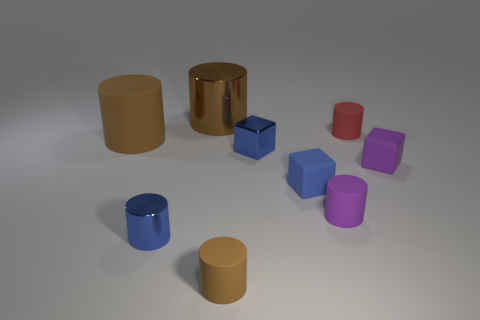The tiny rubber object that is the same color as the shiny cube is what shape?
Your response must be concise. Cube. What number of blue metal objects are the same shape as the tiny brown matte object?
Provide a short and direct response. 1. There is a small purple object that is the same shape as the small brown matte thing; what is its material?
Your response must be concise. Rubber. Is the number of tiny blue matte objects on the left side of the small brown rubber cylinder greater than the number of red cylinders?
Your response must be concise. No. What color is the shiny cube?
Make the answer very short. Blue. There is a rubber object that is right of the rubber cylinder behind the large brown thing in front of the red cylinder; what is its shape?
Give a very brief answer. Cube. What is the brown object that is in front of the tiny red object and behind the small brown matte cylinder made of?
Give a very brief answer. Rubber. The tiny purple object that is right of the tiny purple rubber cylinder in front of the metallic cube is what shape?
Provide a short and direct response. Cube. Is there any other thing that is the same color as the small shiny cylinder?
Give a very brief answer. Yes. There is a blue shiny cube; is it the same size as the brown thing that is in front of the small metal cylinder?
Offer a very short reply. Yes. 